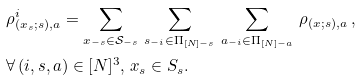Convert formula to latex. <formula><loc_0><loc_0><loc_500><loc_500>& \rho ^ { i } _ { ( x _ { s } ; s ) , a } = \sum _ { x _ { - s } \in \mathcal { S } _ { - s } } \, \sum _ { s _ { - i } \in \Pi _ { [ N ] - s } } \, \sum _ { a _ { - i } \in \Pi _ { [ N ] - a } } \, \rho _ { ( x ; s ) , a } \, , \, \\ & \forall \, ( i , s , a ) \in [ N ] ^ { 3 } , \, x _ { s } \in S _ { s } .</formula> 